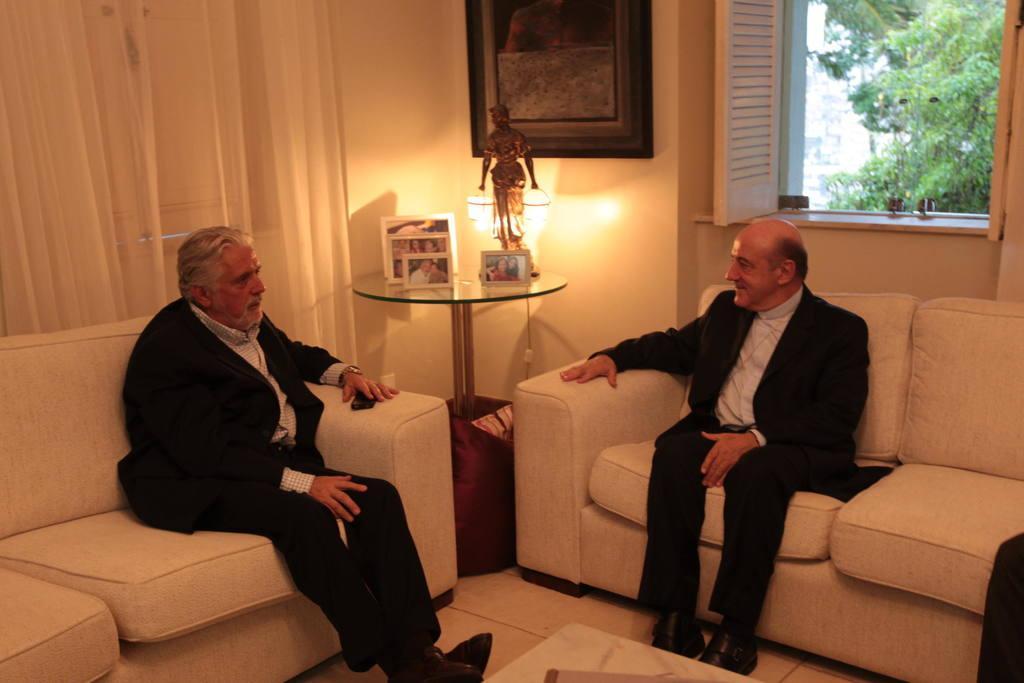Can you describe this image briefly? In the image I can see a room in which there are two people who are sitting on the sofa and a table on which there is a frame, statue and a lamp and also I can see a frame and a window. 